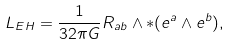Convert formula to latex. <formula><loc_0><loc_0><loc_500><loc_500>L _ { E H } = \frac { 1 } { 3 2 \pi G } R _ { a b } \wedge \ast ( e ^ { a } \wedge e ^ { b } ) ,</formula> 